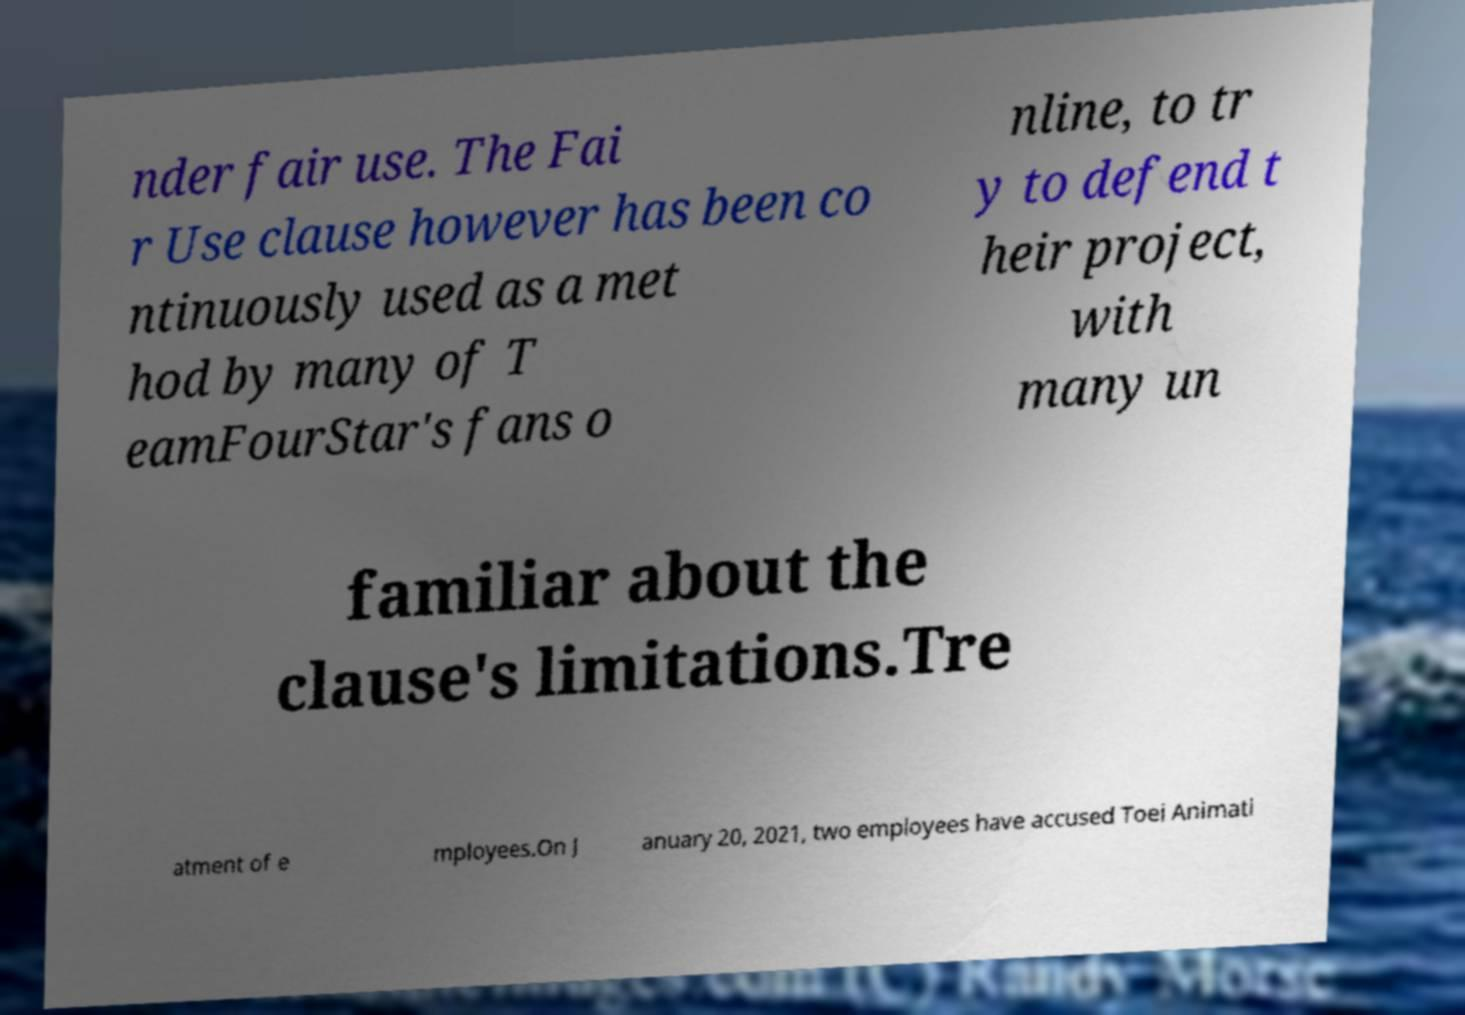Could you assist in decoding the text presented in this image and type it out clearly? nder fair use. The Fai r Use clause however has been co ntinuously used as a met hod by many of T eamFourStar's fans o nline, to tr y to defend t heir project, with many un familiar about the clause's limitations.Tre atment of e mployees.On J anuary 20, 2021, two employees have accused Toei Animati 